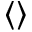Convert formula to latex. <formula><loc_0><loc_0><loc_500><loc_500>\langle \rangle</formula> 